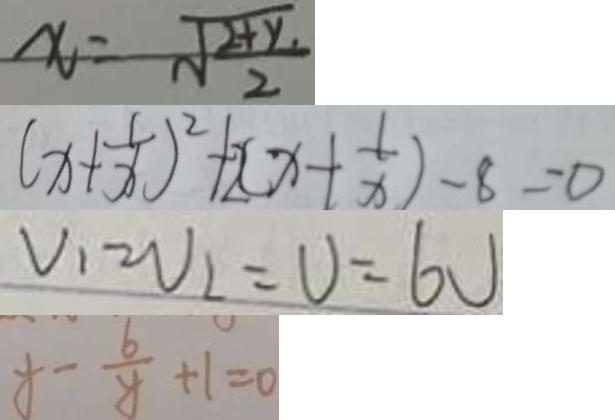<formula> <loc_0><loc_0><loc_500><loc_500>x = \sqrt { \frac { 2 + y } { 2 } } 
 ( x + \frac { 1 } { x } ) ^ { 2 } + 2 ( x + \frac { 1 } { x } ) - 8 = 0 
 V _ { 1 } = V _ { 2 } = V = 6 V 
 x - \frac { 6 } { y } + 1 = 0</formula> 